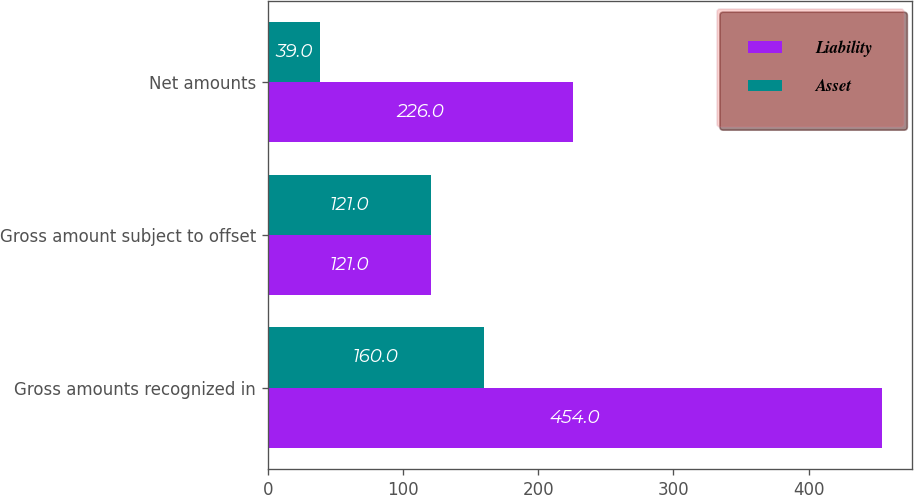Convert chart to OTSL. <chart><loc_0><loc_0><loc_500><loc_500><stacked_bar_chart><ecel><fcel>Gross amounts recognized in<fcel>Gross amount subject to offset<fcel>Net amounts<nl><fcel>Liability<fcel>454<fcel>121<fcel>226<nl><fcel>Asset<fcel>160<fcel>121<fcel>39<nl></chart> 